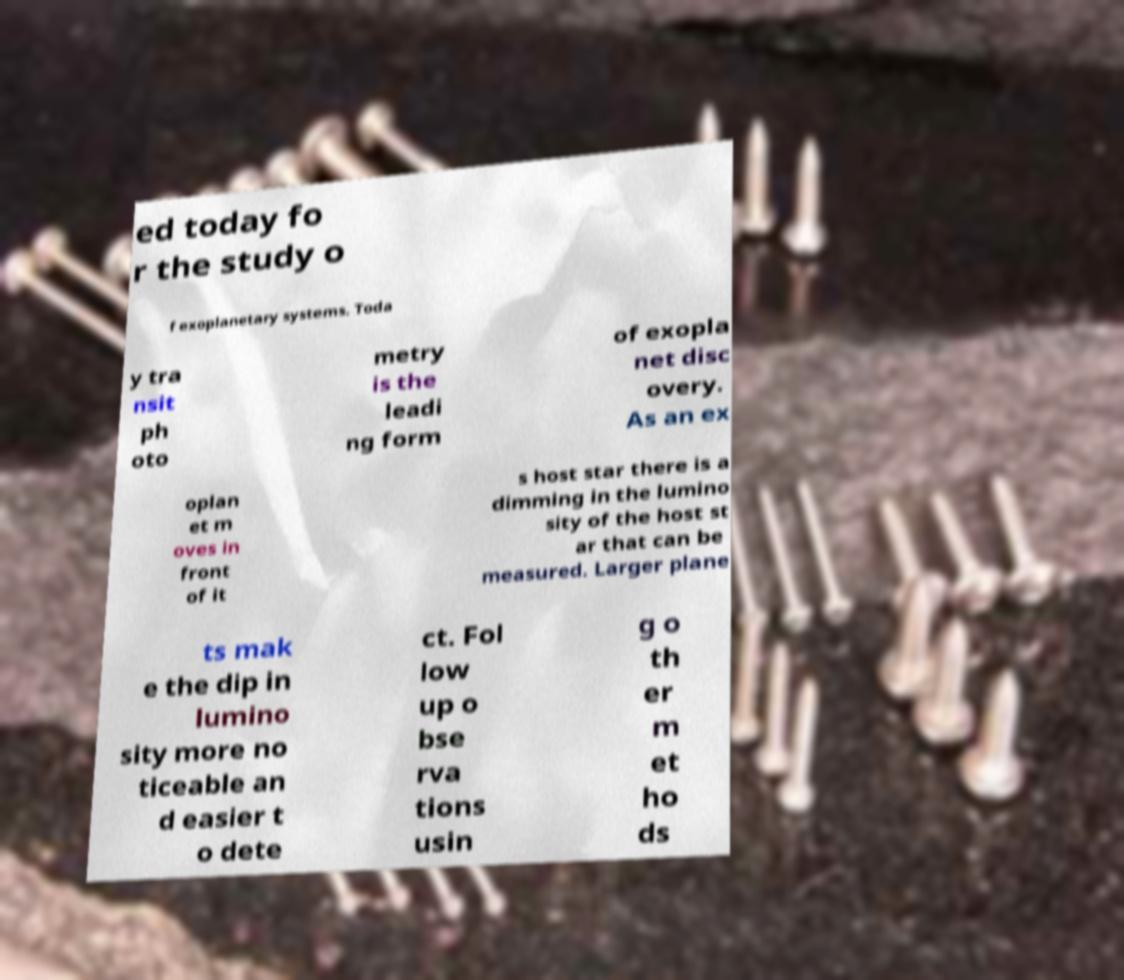I need the written content from this picture converted into text. Can you do that? ed today fo r the study o f exoplanetary systems. Toda y tra nsit ph oto metry is the leadi ng form of exopla net disc overy. As an ex oplan et m oves in front of it s host star there is a dimming in the lumino sity of the host st ar that can be measured. Larger plane ts mak e the dip in lumino sity more no ticeable an d easier t o dete ct. Fol low up o bse rva tions usin g o th er m et ho ds 